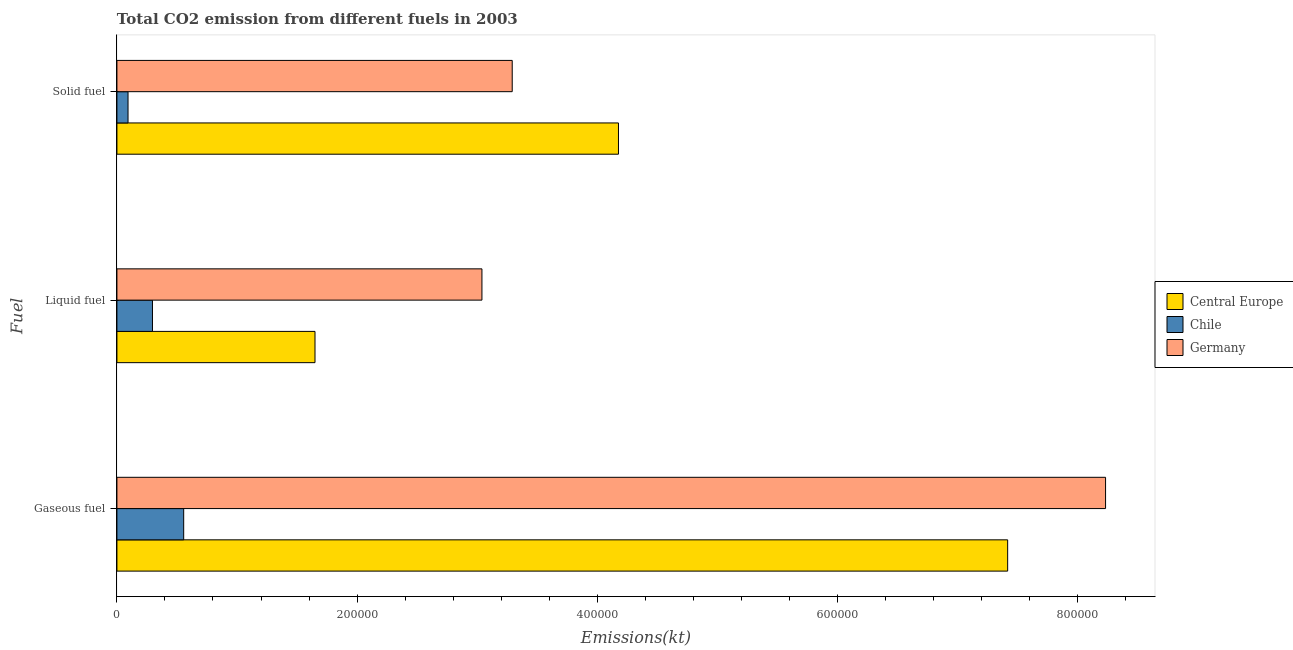How many different coloured bars are there?
Ensure brevity in your answer.  3. How many groups of bars are there?
Keep it short and to the point. 3. Are the number of bars per tick equal to the number of legend labels?
Make the answer very short. Yes. Are the number of bars on each tick of the Y-axis equal?
Offer a terse response. Yes. How many bars are there on the 2nd tick from the top?
Make the answer very short. 3. What is the label of the 3rd group of bars from the top?
Provide a short and direct response. Gaseous fuel. What is the amount of co2 emissions from gaseous fuel in Germany?
Ensure brevity in your answer.  8.23e+05. Across all countries, what is the maximum amount of co2 emissions from solid fuel?
Offer a terse response. 4.18e+05. Across all countries, what is the minimum amount of co2 emissions from liquid fuel?
Keep it short and to the point. 2.96e+04. What is the total amount of co2 emissions from gaseous fuel in the graph?
Offer a terse response. 1.62e+06. What is the difference between the amount of co2 emissions from liquid fuel in Central Europe and that in Chile?
Ensure brevity in your answer.  1.35e+05. What is the difference between the amount of co2 emissions from gaseous fuel in Germany and the amount of co2 emissions from liquid fuel in Chile?
Offer a very short reply. 7.94e+05. What is the average amount of co2 emissions from gaseous fuel per country?
Keep it short and to the point. 5.40e+05. What is the difference between the amount of co2 emissions from liquid fuel and amount of co2 emissions from gaseous fuel in Chile?
Offer a very short reply. -2.60e+04. In how many countries, is the amount of co2 emissions from gaseous fuel greater than 40000 kt?
Offer a terse response. 3. What is the ratio of the amount of co2 emissions from liquid fuel in Germany to that in Chile?
Keep it short and to the point. 10.27. Is the amount of co2 emissions from gaseous fuel in Chile less than that in Germany?
Provide a short and direct response. Yes. What is the difference between the highest and the second highest amount of co2 emissions from gaseous fuel?
Your answer should be compact. 8.15e+04. What is the difference between the highest and the lowest amount of co2 emissions from solid fuel?
Give a very brief answer. 4.08e+05. In how many countries, is the amount of co2 emissions from solid fuel greater than the average amount of co2 emissions from solid fuel taken over all countries?
Make the answer very short. 2. Is the sum of the amount of co2 emissions from gaseous fuel in Chile and Germany greater than the maximum amount of co2 emissions from liquid fuel across all countries?
Provide a short and direct response. Yes. What does the 1st bar from the top in Gaseous fuel represents?
Keep it short and to the point. Germany. What does the 3rd bar from the bottom in Gaseous fuel represents?
Your response must be concise. Germany. Is it the case that in every country, the sum of the amount of co2 emissions from gaseous fuel and amount of co2 emissions from liquid fuel is greater than the amount of co2 emissions from solid fuel?
Your answer should be compact. Yes. Are all the bars in the graph horizontal?
Ensure brevity in your answer.  Yes. How many countries are there in the graph?
Give a very brief answer. 3. Are the values on the major ticks of X-axis written in scientific E-notation?
Your response must be concise. No. Does the graph contain grids?
Provide a short and direct response. No. How many legend labels are there?
Provide a succinct answer. 3. How are the legend labels stacked?
Your response must be concise. Vertical. What is the title of the graph?
Keep it short and to the point. Total CO2 emission from different fuels in 2003. Does "Latin America(developing only)" appear as one of the legend labels in the graph?
Your response must be concise. No. What is the label or title of the X-axis?
Offer a terse response. Emissions(kt). What is the label or title of the Y-axis?
Keep it short and to the point. Fuel. What is the Emissions(kt) in Central Europe in Gaseous fuel?
Ensure brevity in your answer.  7.42e+05. What is the Emissions(kt) of Chile in Gaseous fuel?
Your response must be concise. 5.56e+04. What is the Emissions(kt) in Germany in Gaseous fuel?
Keep it short and to the point. 8.23e+05. What is the Emissions(kt) in Central Europe in Liquid fuel?
Offer a terse response. 1.65e+05. What is the Emissions(kt) of Chile in Liquid fuel?
Offer a terse response. 2.96e+04. What is the Emissions(kt) of Germany in Liquid fuel?
Offer a very short reply. 3.04e+05. What is the Emissions(kt) of Central Europe in Solid fuel?
Provide a succinct answer. 4.18e+05. What is the Emissions(kt) in Chile in Solid fuel?
Your answer should be compact. 9251.84. What is the Emissions(kt) of Germany in Solid fuel?
Offer a terse response. 3.29e+05. Across all Fuel, what is the maximum Emissions(kt) in Central Europe?
Provide a succinct answer. 7.42e+05. Across all Fuel, what is the maximum Emissions(kt) in Chile?
Your answer should be very brief. 5.56e+04. Across all Fuel, what is the maximum Emissions(kt) in Germany?
Keep it short and to the point. 8.23e+05. Across all Fuel, what is the minimum Emissions(kt) of Central Europe?
Offer a terse response. 1.65e+05. Across all Fuel, what is the minimum Emissions(kt) of Chile?
Your response must be concise. 9251.84. Across all Fuel, what is the minimum Emissions(kt) of Germany?
Offer a terse response. 3.04e+05. What is the total Emissions(kt) in Central Europe in the graph?
Your response must be concise. 1.32e+06. What is the total Emissions(kt) of Chile in the graph?
Your answer should be compact. 9.45e+04. What is the total Emissions(kt) in Germany in the graph?
Your answer should be compact. 1.46e+06. What is the difference between the Emissions(kt) of Central Europe in Gaseous fuel and that in Liquid fuel?
Give a very brief answer. 5.77e+05. What is the difference between the Emissions(kt) of Chile in Gaseous fuel and that in Liquid fuel?
Offer a terse response. 2.60e+04. What is the difference between the Emissions(kt) of Germany in Gaseous fuel and that in Liquid fuel?
Make the answer very short. 5.19e+05. What is the difference between the Emissions(kt) in Central Europe in Gaseous fuel and that in Solid fuel?
Give a very brief answer. 3.24e+05. What is the difference between the Emissions(kt) of Chile in Gaseous fuel and that in Solid fuel?
Offer a very short reply. 4.64e+04. What is the difference between the Emissions(kt) of Germany in Gaseous fuel and that in Solid fuel?
Provide a short and direct response. 4.94e+05. What is the difference between the Emissions(kt) in Central Europe in Liquid fuel and that in Solid fuel?
Your answer should be compact. -2.53e+05. What is the difference between the Emissions(kt) in Chile in Liquid fuel and that in Solid fuel?
Keep it short and to the point. 2.04e+04. What is the difference between the Emissions(kt) in Germany in Liquid fuel and that in Solid fuel?
Ensure brevity in your answer.  -2.52e+04. What is the difference between the Emissions(kt) of Central Europe in Gaseous fuel and the Emissions(kt) of Chile in Liquid fuel?
Provide a succinct answer. 7.12e+05. What is the difference between the Emissions(kt) in Central Europe in Gaseous fuel and the Emissions(kt) in Germany in Liquid fuel?
Keep it short and to the point. 4.38e+05. What is the difference between the Emissions(kt) of Chile in Gaseous fuel and the Emissions(kt) of Germany in Liquid fuel?
Give a very brief answer. -2.48e+05. What is the difference between the Emissions(kt) of Central Europe in Gaseous fuel and the Emissions(kt) of Chile in Solid fuel?
Provide a succinct answer. 7.33e+05. What is the difference between the Emissions(kt) in Central Europe in Gaseous fuel and the Emissions(kt) in Germany in Solid fuel?
Provide a short and direct response. 4.13e+05. What is the difference between the Emissions(kt) in Chile in Gaseous fuel and the Emissions(kt) in Germany in Solid fuel?
Make the answer very short. -2.74e+05. What is the difference between the Emissions(kt) of Central Europe in Liquid fuel and the Emissions(kt) of Chile in Solid fuel?
Your answer should be very brief. 1.56e+05. What is the difference between the Emissions(kt) of Central Europe in Liquid fuel and the Emissions(kt) of Germany in Solid fuel?
Offer a very short reply. -1.64e+05. What is the difference between the Emissions(kt) of Chile in Liquid fuel and the Emissions(kt) of Germany in Solid fuel?
Your response must be concise. -3.00e+05. What is the average Emissions(kt) in Central Europe per Fuel?
Make the answer very short. 4.42e+05. What is the average Emissions(kt) of Chile per Fuel?
Provide a succinct answer. 3.15e+04. What is the average Emissions(kt) of Germany per Fuel?
Offer a very short reply. 4.86e+05. What is the difference between the Emissions(kt) of Central Europe and Emissions(kt) of Chile in Gaseous fuel?
Provide a short and direct response. 6.86e+05. What is the difference between the Emissions(kt) of Central Europe and Emissions(kt) of Germany in Gaseous fuel?
Offer a very short reply. -8.15e+04. What is the difference between the Emissions(kt) in Chile and Emissions(kt) in Germany in Gaseous fuel?
Your response must be concise. -7.68e+05. What is the difference between the Emissions(kt) of Central Europe and Emissions(kt) of Chile in Liquid fuel?
Provide a succinct answer. 1.35e+05. What is the difference between the Emissions(kt) in Central Europe and Emissions(kt) in Germany in Liquid fuel?
Your answer should be very brief. -1.39e+05. What is the difference between the Emissions(kt) of Chile and Emissions(kt) of Germany in Liquid fuel?
Offer a terse response. -2.74e+05. What is the difference between the Emissions(kt) in Central Europe and Emissions(kt) in Chile in Solid fuel?
Offer a terse response. 4.08e+05. What is the difference between the Emissions(kt) of Central Europe and Emissions(kt) of Germany in Solid fuel?
Your answer should be compact. 8.85e+04. What is the difference between the Emissions(kt) of Chile and Emissions(kt) of Germany in Solid fuel?
Your answer should be very brief. -3.20e+05. What is the ratio of the Emissions(kt) of Central Europe in Gaseous fuel to that in Liquid fuel?
Keep it short and to the point. 4.5. What is the ratio of the Emissions(kt) in Chile in Gaseous fuel to that in Liquid fuel?
Ensure brevity in your answer.  1.88. What is the ratio of the Emissions(kt) of Germany in Gaseous fuel to that in Liquid fuel?
Provide a short and direct response. 2.71. What is the ratio of the Emissions(kt) in Central Europe in Gaseous fuel to that in Solid fuel?
Offer a terse response. 1.78. What is the ratio of the Emissions(kt) of Chile in Gaseous fuel to that in Solid fuel?
Offer a terse response. 6.01. What is the ratio of the Emissions(kt) of Germany in Gaseous fuel to that in Solid fuel?
Your response must be concise. 2.5. What is the ratio of the Emissions(kt) of Central Europe in Liquid fuel to that in Solid fuel?
Your answer should be very brief. 0.39. What is the ratio of the Emissions(kt) in Chile in Liquid fuel to that in Solid fuel?
Offer a terse response. 3.2. What is the ratio of the Emissions(kt) in Germany in Liquid fuel to that in Solid fuel?
Make the answer very short. 0.92. What is the difference between the highest and the second highest Emissions(kt) in Central Europe?
Ensure brevity in your answer.  3.24e+05. What is the difference between the highest and the second highest Emissions(kt) in Chile?
Provide a succinct answer. 2.60e+04. What is the difference between the highest and the second highest Emissions(kt) in Germany?
Make the answer very short. 4.94e+05. What is the difference between the highest and the lowest Emissions(kt) of Central Europe?
Give a very brief answer. 5.77e+05. What is the difference between the highest and the lowest Emissions(kt) of Chile?
Your answer should be compact. 4.64e+04. What is the difference between the highest and the lowest Emissions(kt) of Germany?
Give a very brief answer. 5.19e+05. 